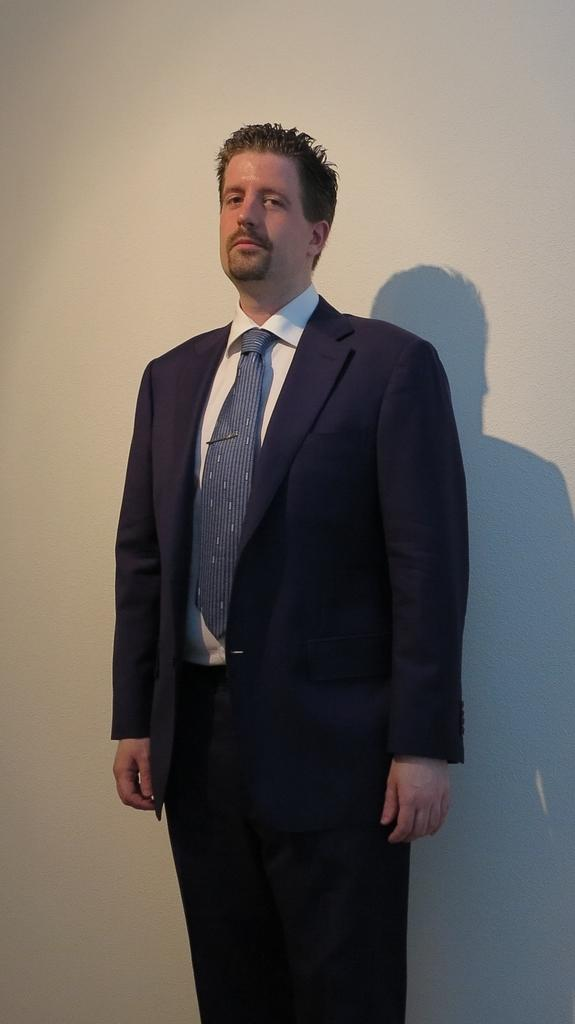What is the main subject in the foreground of the image? There is a man standing in the foreground of the image. What can be seen in the background of the image? There is a wall in the background of the image. What is a notable detail about the man's presence in the image? The man's shadow is visible on the wall. What is the clam's opinion on the man's shadow in the image? There is no clam present in the image, so it cannot have an opinion on the man's shadow. 